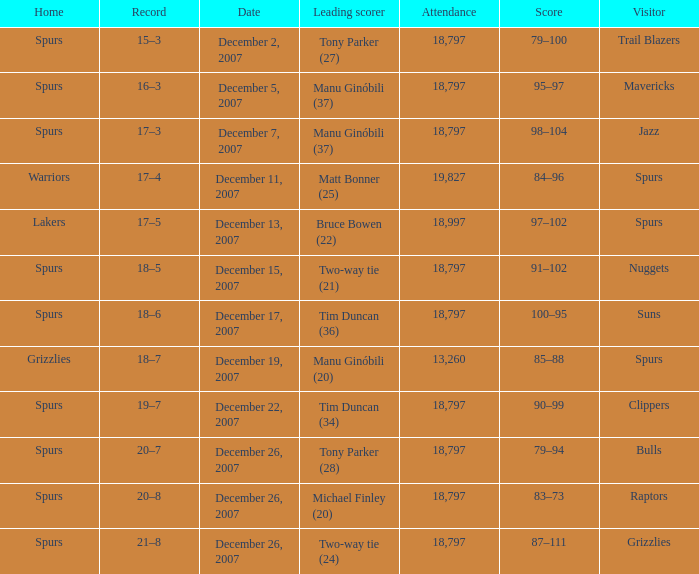What is the record of the game on December 5, 2007? 16–3. Could you parse the entire table? {'header': ['Home', 'Record', 'Date', 'Leading scorer', 'Attendance', 'Score', 'Visitor'], 'rows': [['Spurs', '15–3', 'December 2, 2007', 'Tony Parker (27)', '18,797', '79–100', 'Trail Blazers'], ['Spurs', '16–3', 'December 5, 2007', 'Manu Ginóbili (37)', '18,797', '95–97', 'Mavericks'], ['Spurs', '17–3', 'December 7, 2007', 'Manu Ginóbili (37)', '18,797', '98–104', 'Jazz'], ['Warriors', '17–4', 'December 11, 2007', 'Matt Bonner (25)', '19,827', '84–96', 'Spurs'], ['Lakers', '17–5', 'December 13, 2007', 'Bruce Bowen (22)', '18,997', '97–102', 'Spurs'], ['Spurs', '18–5', 'December 15, 2007', 'Two-way tie (21)', '18,797', '91–102', 'Nuggets'], ['Spurs', '18–6', 'December 17, 2007', 'Tim Duncan (36)', '18,797', '100–95', 'Suns'], ['Grizzlies', '18–7', 'December 19, 2007', 'Manu Ginóbili (20)', '13,260', '85–88', 'Spurs'], ['Spurs', '19–7', 'December 22, 2007', 'Tim Duncan (34)', '18,797', '90–99', 'Clippers'], ['Spurs', '20–7', 'December 26, 2007', 'Tony Parker (28)', '18,797', '79–94', 'Bulls'], ['Spurs', '20–8', 'December 26, 2007', 'Michael Finley (20)', '18,797', '83–73', 'Raptors'], ['Spurs', '21–8', 'December 26, 2007', 'Two-way tie (24)', '18,797', '87–111', 'Grizzlies']]} 